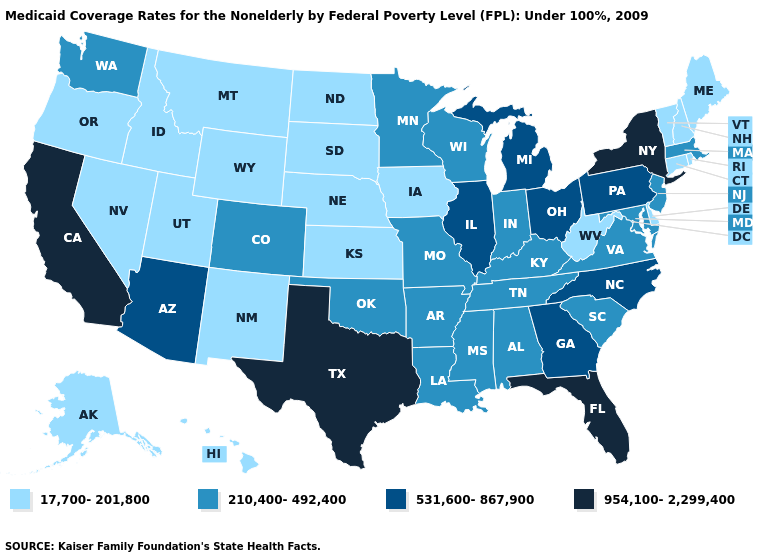Does Pennsylvania have the highest value in the USA?
Answer briefly. No. Is the legend a continuous bar?
Write a very short answer. No. What is the value of Indiana?
Short answer required. 210,400-492,400. Name the states that have a value in the range 954,100-2,299,400?
Be succinct. California, Florida, New York, Texas. Name the states that have a value in the range 531,600-867,900?
Concise answer only. Arizona, Georgia, Illinois, Michigan, North Carolina, Ohio, Pennsylvania. What is the value of New York?
Concise answer only. 954,100-2,299,400. Which states hav the highest value in the MidWest?
Answer briefly. Illinois, Michigan, Ohio. Among the states that border South Dakota , which have the lowest value?
Short answer required. Iowa, Montana, Nebraska, North Dakota, Wyoming. What is the value of Colorado?
Quick response, please. 210,400-492,400. What is the highest value in the Northeast ?
Answer briefly. 954,100-2,299,400. What is the highest value in states that border Minnesota?
Keep it brief. 210,400-492,400. Among the states that border Indiana , which have the lowest value?
Write a very short answer. Kentucky. What is the value of Utah?
Answer briefly. 17,700-201,800. Is the legend a continuous bar?
Short answer required. No. What is the highest value in states that border Missouri?
Short answer required. 531,600-867,900. 